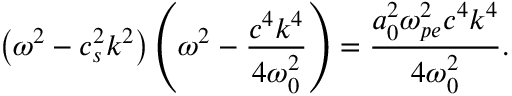<formula> <loc_0><loc_0><loc_500><loc_500>\left ( \omega ^ { 2 } - c _ { s } ^ { 2 } k ^ { 2 } \right ) \left ( \omega ^ { 2 } - \frac { c ^ { 4 } k ^ { 4 } } { 4 \omega _ { 0 } ^ { 2 } } \right ) = \frac { a _ { 0 } ^ { 2 } \omega _ { p e } ^ { 2 } c ^ { 4 } k ^ { 4 } } { 4 \omega _ { 0 } ^ { 2 } } .</formula> 